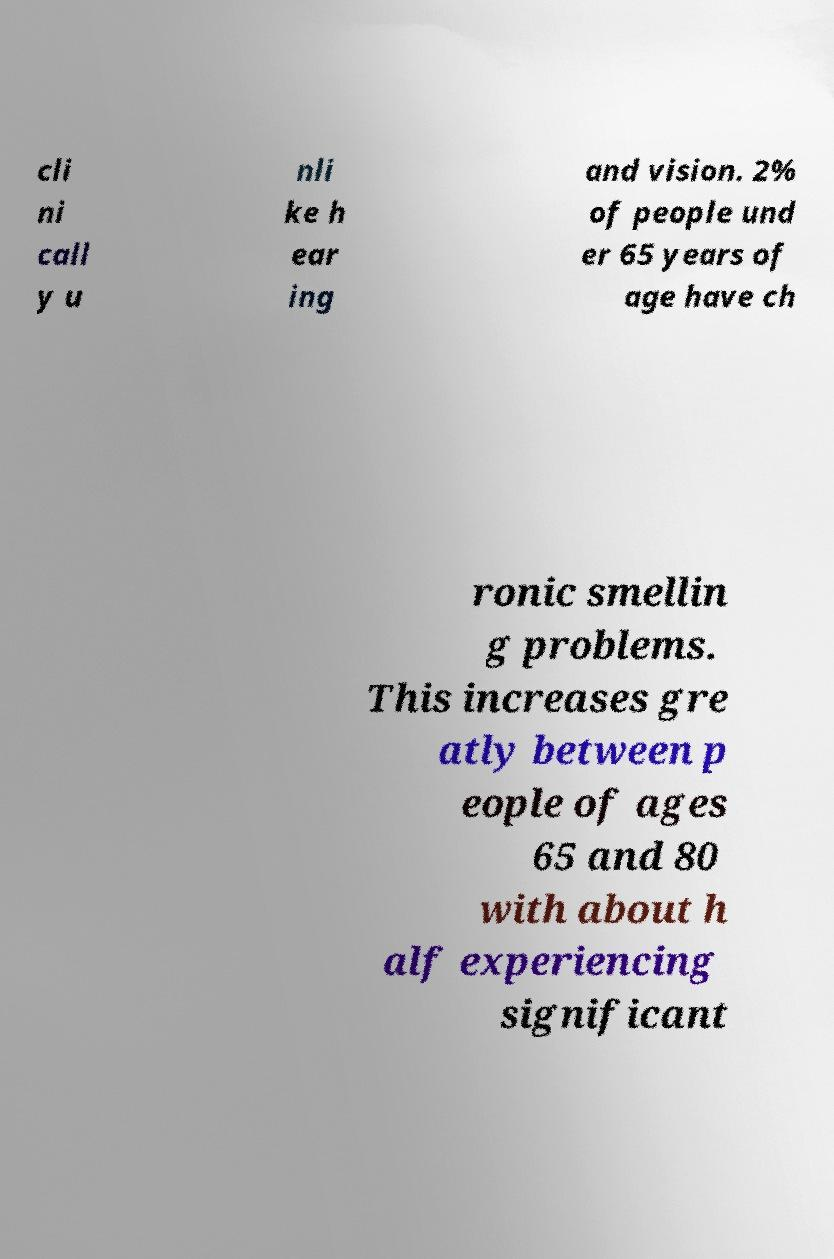What messages or text are displayed in this image? I need them in a readable, typed format. cli ni call y u nli ke h ear ing and vision. 2% of people und er 65 years of age have ch ronic smellin g problems. This increases gre atly between p eople of ages 65 and 80 with about h alf experiencing significant 